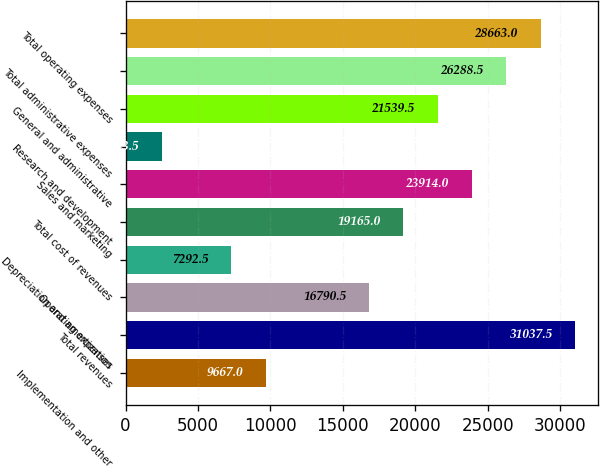Convert chart. <chart><loc_0><loc_0><loc_500><loc_500><bar_chart><fcel>Implementation and other<fcel>Total revenues<fcel>Operating expenses<fcel>Depreciation and amortization<fcel>Total cost of revenues<fcel>Sales and marketing<fcel>Research and development<fcel>General and administrative<fcel>Total administrative expenses<fcel>Total operating expenses<nl><fcel>9667<fcel>31037.5<fcel>16790.5<fcel>7292.5<fcel>19165<fcel>23914<fcel>2543.5<fcel>21539.5<fcel>26288.5<fcel>28663<nl></chart> 